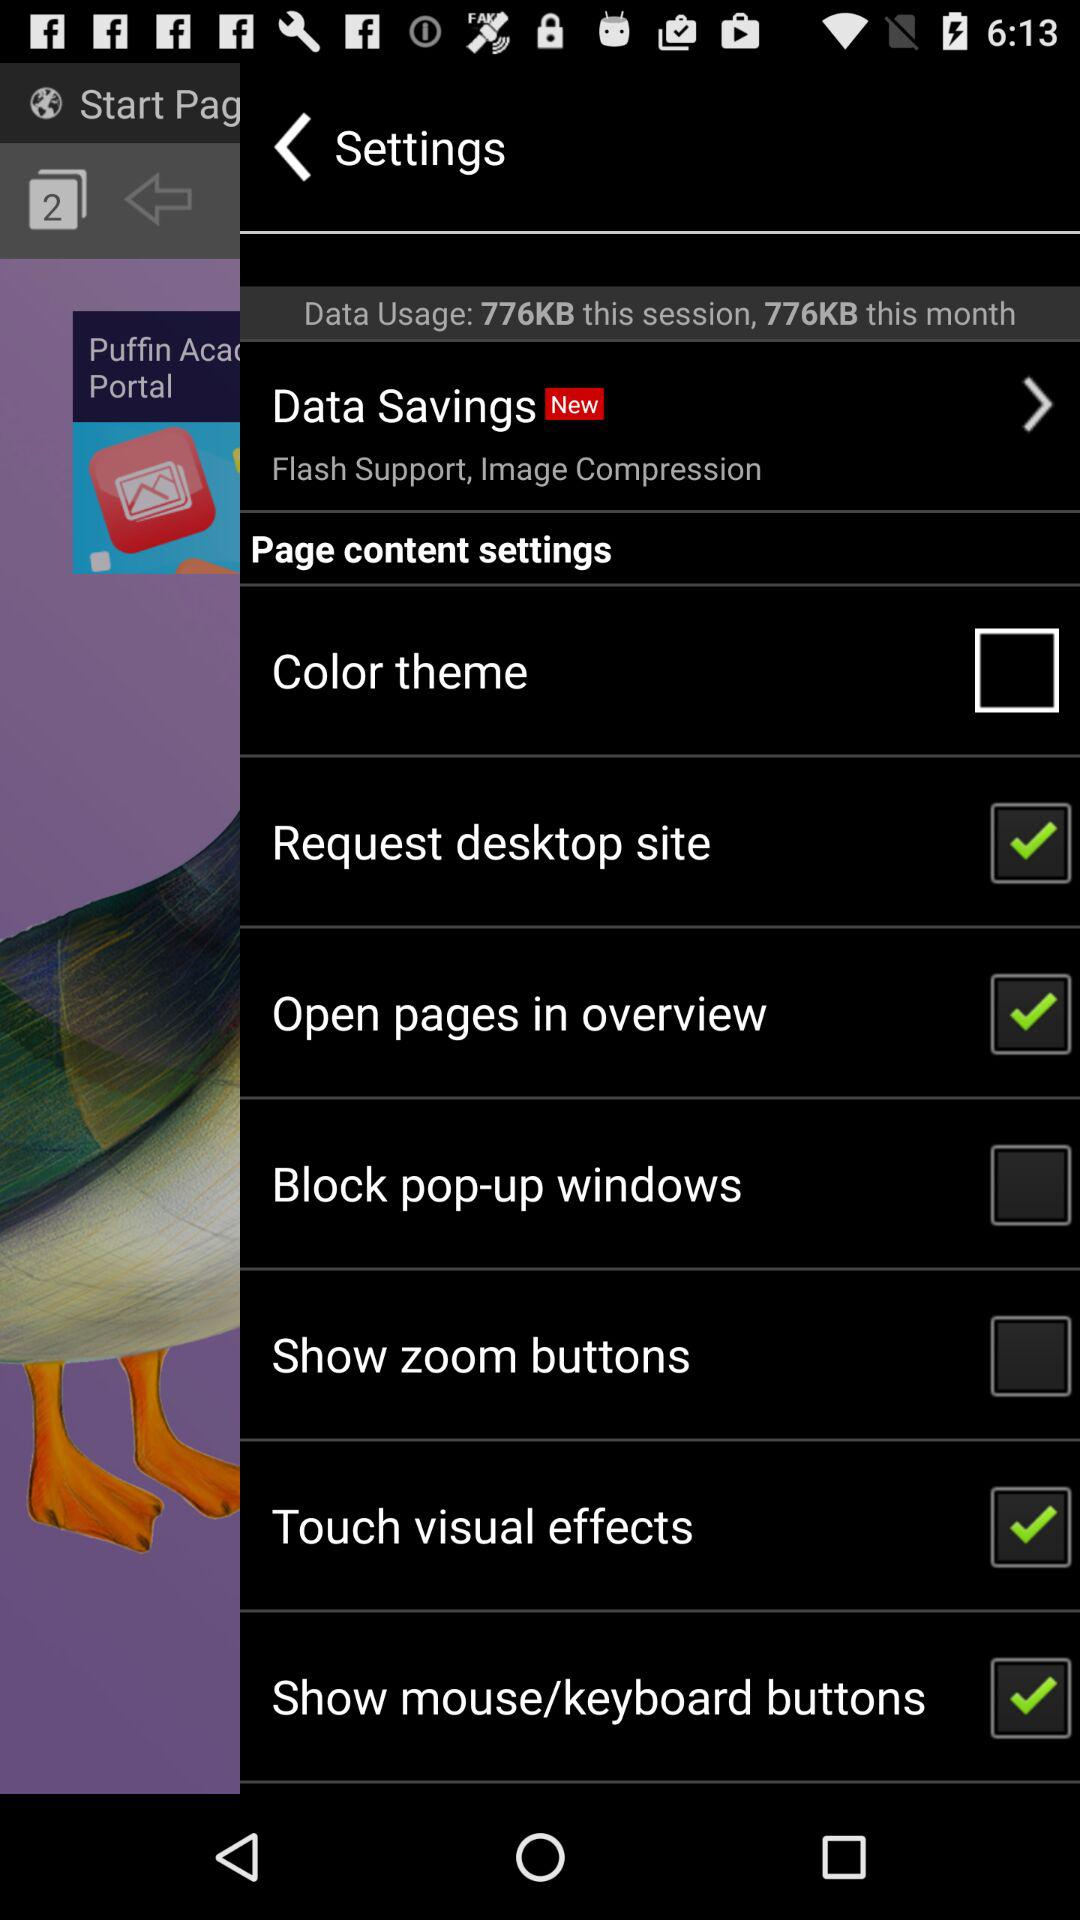How much data have you used this month? You have used 776 KB of data. 